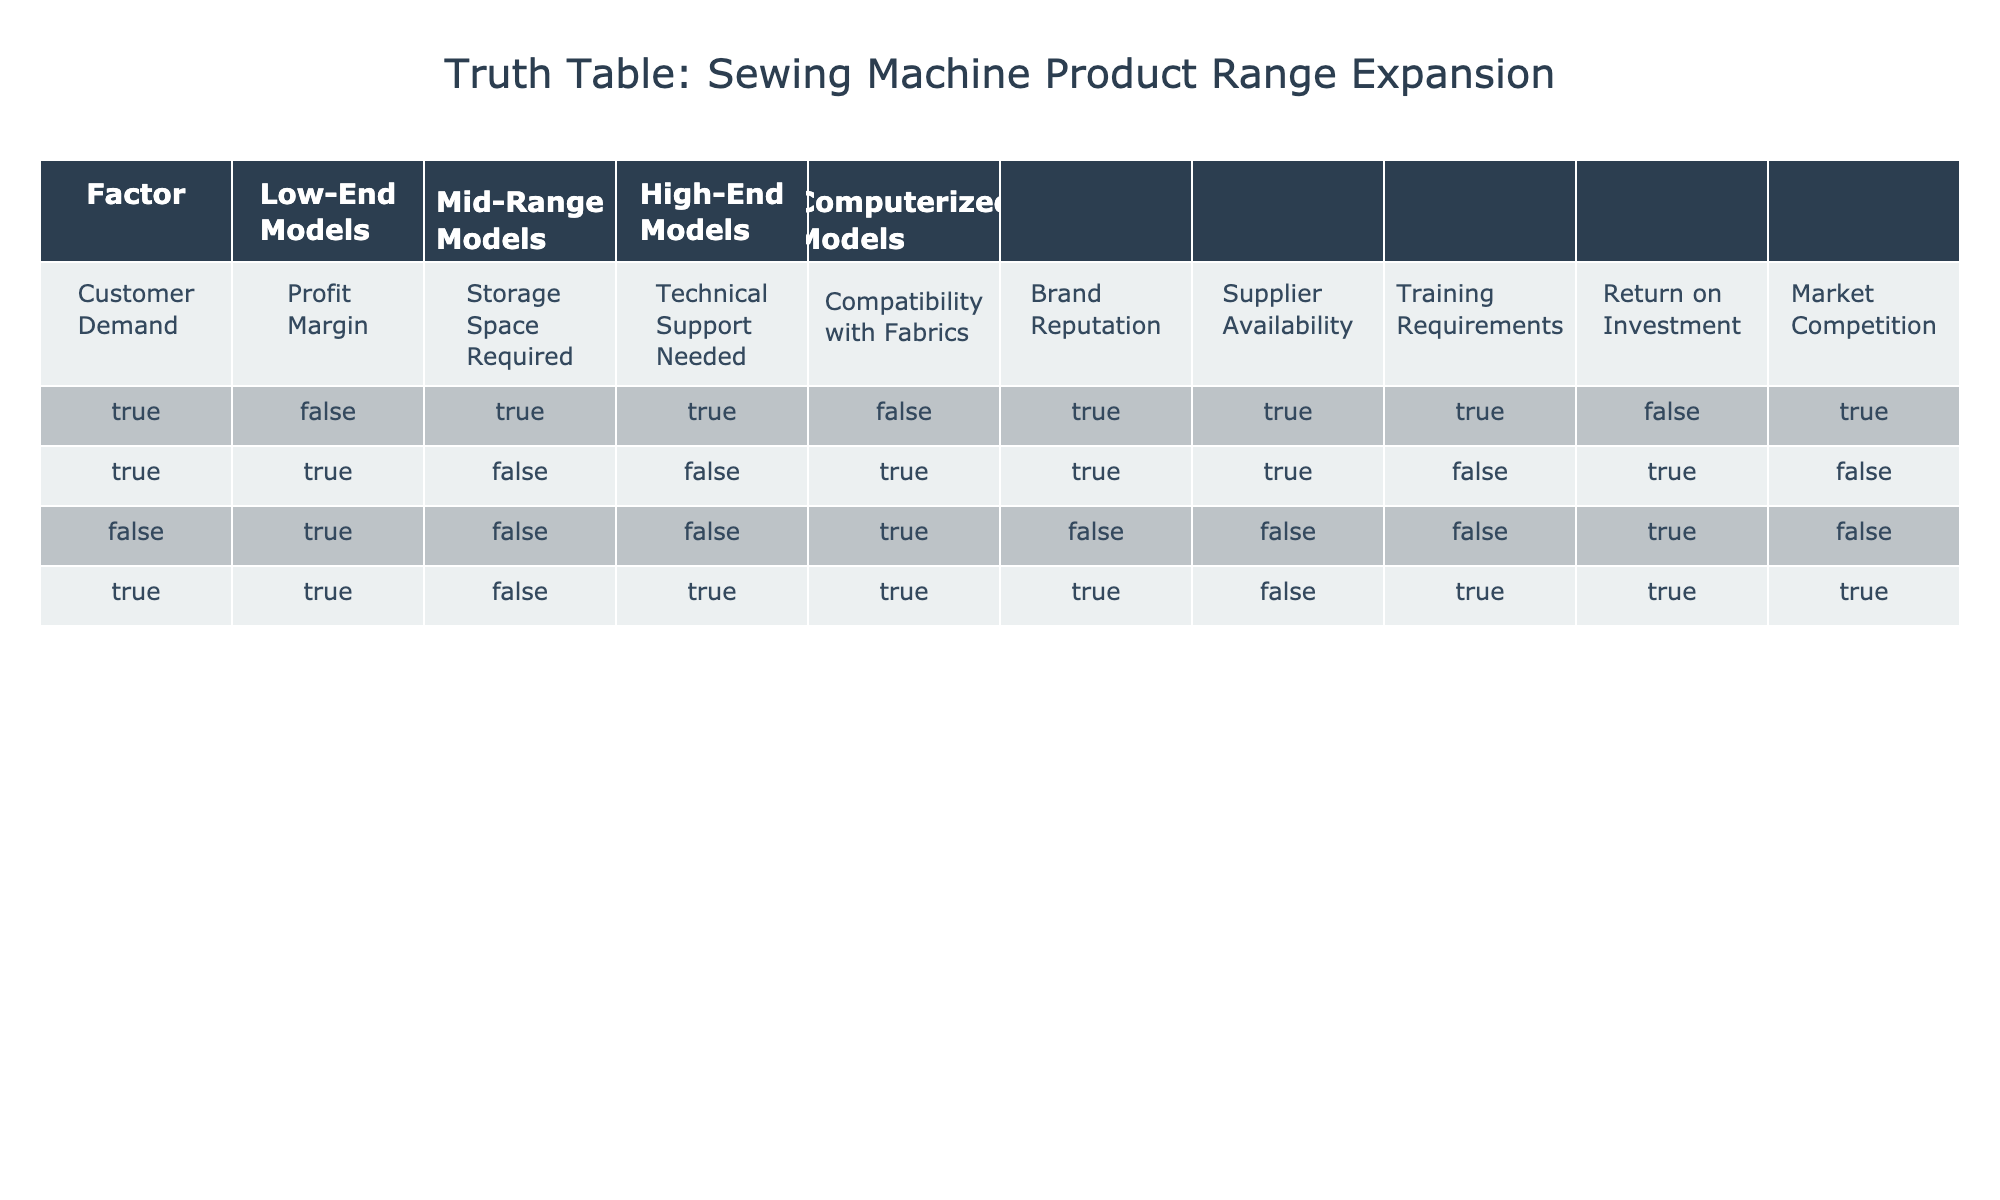What models require the most technical support? From the table, both low-end and computerized models require technical support (marked TRUE), while mid-range and high-end models do not (marked FALSE). Therefore, the low-end and computerized models require the most technical support.
Answer: Low-end and Computerized Models Which types of models have the highest profit margins? According to the table, mid-range, high-end, and computerized models are marked TRUE for profit margin, while low-end models are marked FALSE. Therefore, mid-range, high-end, and computerized models have the highest profit margins.
Answer: Mid-Range, High-End, and Computerized Models Is there a model type that meets customer demand but has a low return on investment? The table indicates that low-end models and high-end models do not meet customer demand (FALSE) and have a low return on investment (FALSE). Therefore, there are no models that meet customer demand and have a low return on investment.
Answer: No Which model types have a TRUE value for both compatibility with fabrics and profit margin? Mid-range, high-end, and computerized models are marked TRUE for compatibility with fabrics in the table. For profit margin, mid-range, high-end, and computerized models are also marked TRUE. Thus, all three model types fit this criteria.
Answer: Mid-Range, High-End, and Computerized Models What is the relationship between supplier availability and technical support needed for the models? From the table, low-end models require technical support (TRUE) and have TRUE for supplier availability, whereas mid-range also has TRUE for both factors. High-end models do not require technical support (FALSE) and are also not available from suppliers (FALSE). Thus, low-end and mid-range models show a positive relationship between supplier availability and technical support needed.
Answer: Low-End and Mid-Range Models Which model type has the least storage space required? The table indicates that low-end models have TRUE for storage space required, while mid-range, high-end, and computerized models have FALSE, meaning they do not need storage space. Therefore, low-end models need the least storage space.
Answer: Low-End Models Do mid-range models require more training compared to high-end models? According to the table, mid-range models have a FALSE value for training requirements, while high-end models also have a FALSE value. Thus, neither mid-range nor high-end models require training, and there is no difference between them.
Answer: No Difference What factors favor the inclusion of computerized models in the product range? Computerized models are marked TRUE for customer demand, profit margin, compatibility with fabrics, and market competition. This indicates that they have favorable conditions for inclusion since they align with customer expectations, profit potential, and market conditions.
Answer: Customer Demand, Profit Margin, Compatibility with Fabrics, Market Competition 